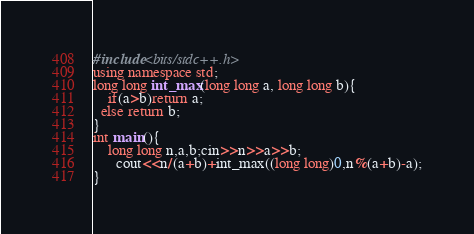Convert code to text. <code><loc_0><loc_0><loc_500><loc_500><_C++_>#include<bits/stdc++.h>
using namespace std;
long long int_max(long long a, long long b){
	if(a>b)return a;
  else return b;
}
int main(){
	long long n,a,b;cin>>n>>a>>b;
      cout<<n/(a+b)+int_max((long long)0,n%(a+b)-a);
}</code> 